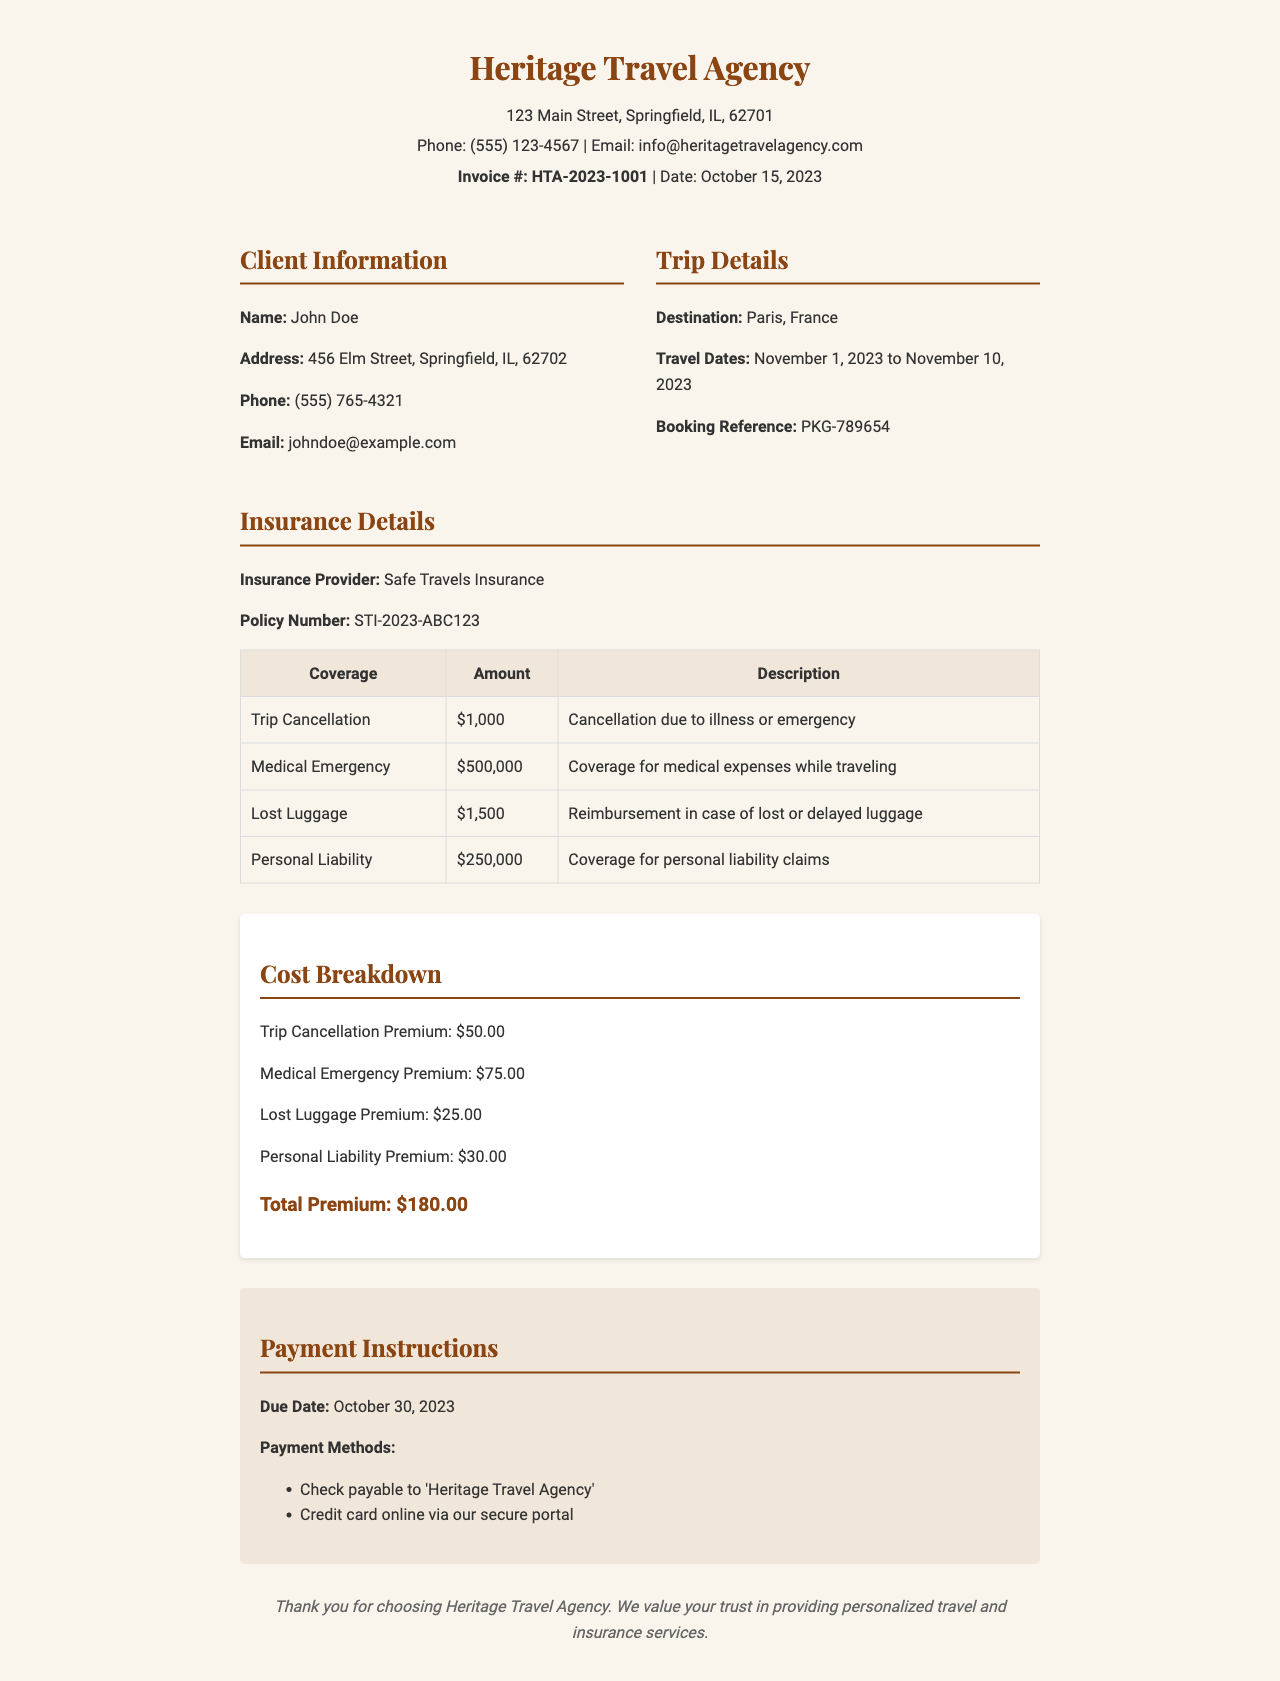What is the invoice number? The invoice number is specified in the document as Invoice #: HTA-2023-1001.
Answer: HTA-2023-1001 Who is the insurance provider? The document states that the insurance provider is Safe Travels Insurance.
Answer: Safe Travels Insurance What is the due date for payment? The due date for payment is listed in the payment instructions section as October 30, 2023.
Answer: October 30, 2023 How much is the premium for Medical Emergency coverage? The premium amount for Medical Emergency coverage is found in the cost breakdown section as $75.00.
Answer: $75.00 What is the total premium amount? The total premium amount is calculated in the cost breakdown section as $180.00.
Answer: $180.00 What is the coverage amount for Lost Luggage? The coverage amount for Lost Luggage is presented in the insurance details as $1,500.
Answer: $1,500 What method of payment is mentioned for checks? The document indicates that checks should be made payable to 'Heritage Travel Agency'.
Answer: Heritage Travel Agency What type of insurance is provided? The document states that the insurance is for travel purposes.
Answer: Travel insurance What is the travel destination mentioned in the document? The travel destination for the client's trip is specified as Paris, France.
Answer: Paris, France How long is the trip duration? The travel dates specified are from November 1, 2023, to November 10, 2023, indicating a duration of 10 days.
Answer: 10 days 